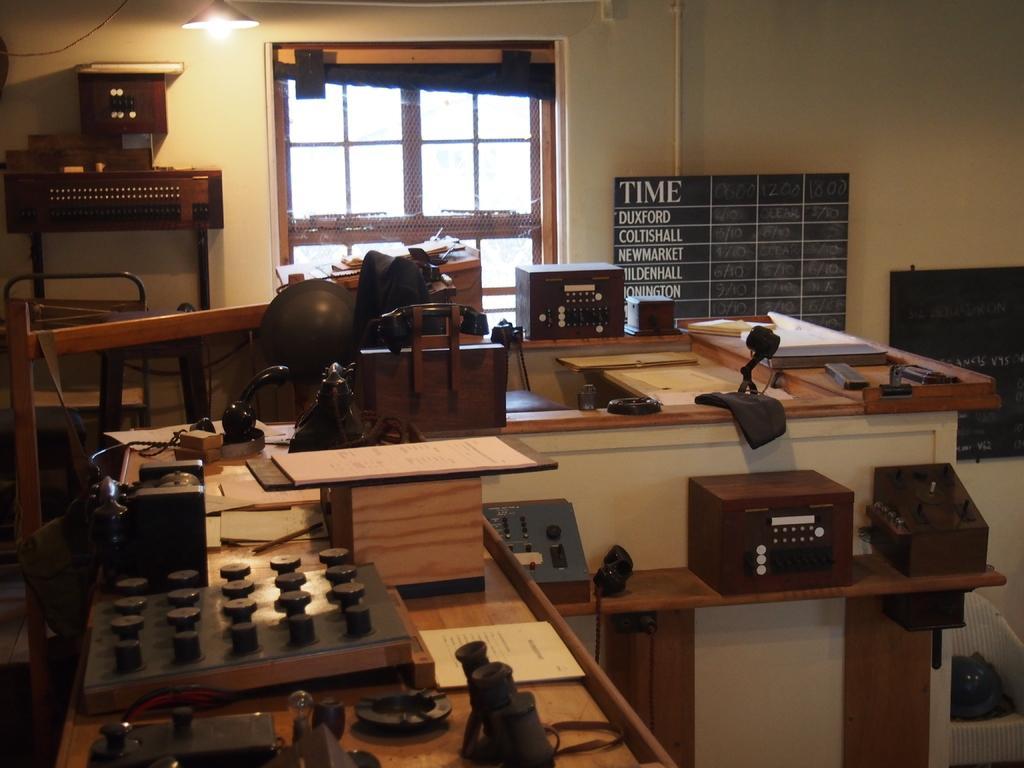Describe this image in one or two sentences. In this image there are tabulated, on that table there are electrical items, in the background there is wall to that wall there is a window and boards on one board there is some text. 